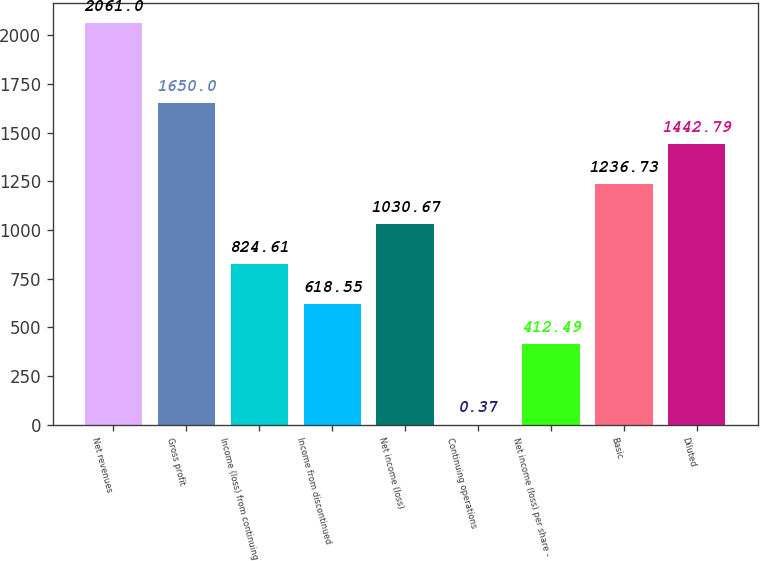Convert chart. <chart><loc_0><loc_0><loc_500><loc_500><bar_chart><fcel>Net revenues<fcel>Gross profit<fcel>Income (loss) from continuing<fcel>Income from discontinued<fcel>Net income (loss)<fcel>Continuing operations<fcel>Net income (loss) per share -<fcel>Basic<fcel>Diluted<nl><fcel>2061<fcel>1650<fcel>824.61<fcel>618.55<fcel>1030.67<fcel>0.37<fcel>412.49<fcel>1236.73<fcel>1442.79<nl></chart> 